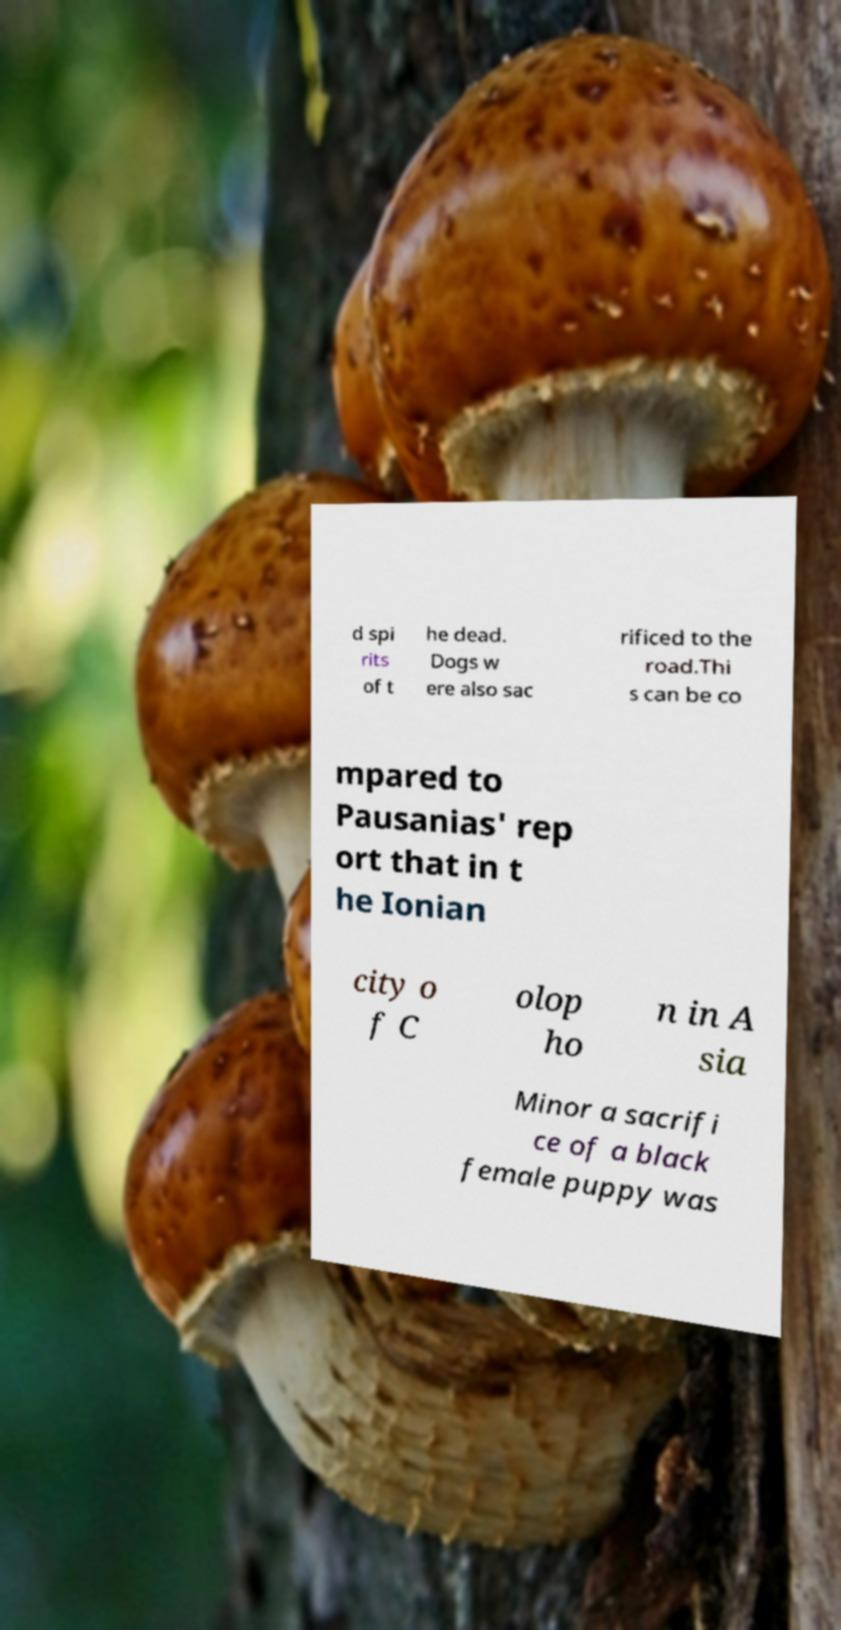Can you read and provide the text displayed in the image?This photo seems to have some interesting text. Can you extract and type it out for me? d spi rits of t he dead. Dogs w ere also sac rificed to the road.Thi s can be co mpared to Pausanias' rep ort that in t he Ionian city o f C olop ho n in A sia Minor a sacrifi ce of a black female puppy was 